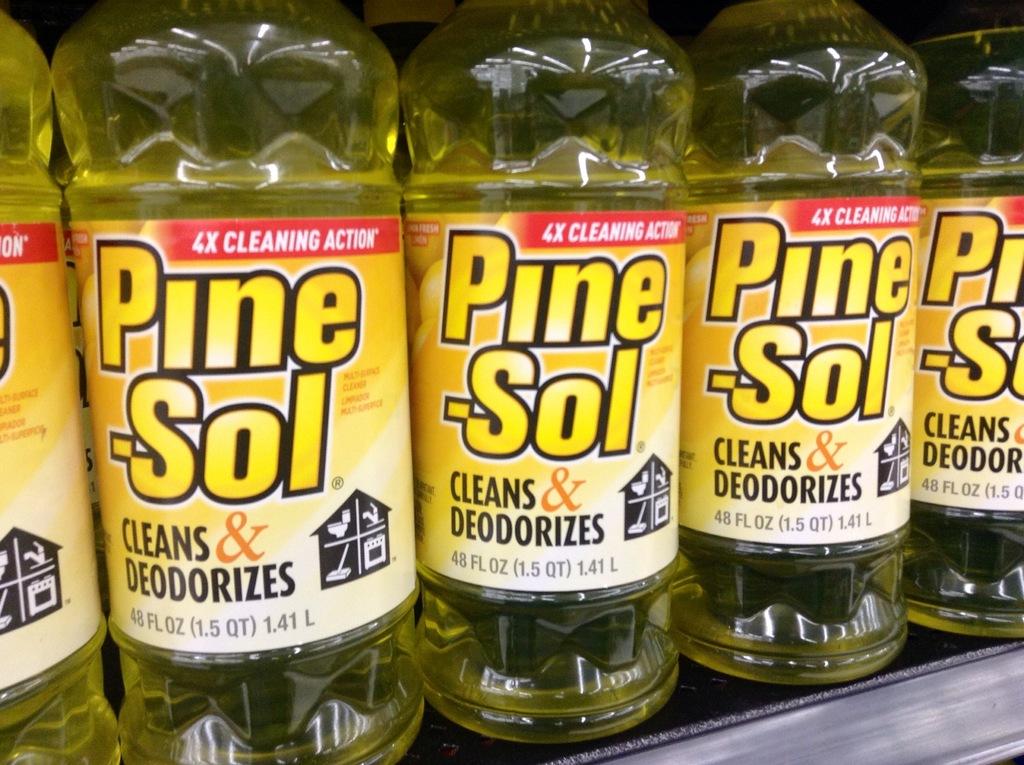How much cleaning action?
Offer a very short reply. 4x. What is in the bottle according to the label?
Your response must be concise. Pine-sol. 